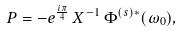Convert formula to latex. <formula><loc_0><loc_0><loc_500><loc_500>P = - e ^ { \frac { i \pi } { 4 } } \, X ^ { - 1 } \, \Phi ^ { ( s ) * } ( \omega _ { 0 } ) ,</formula> 